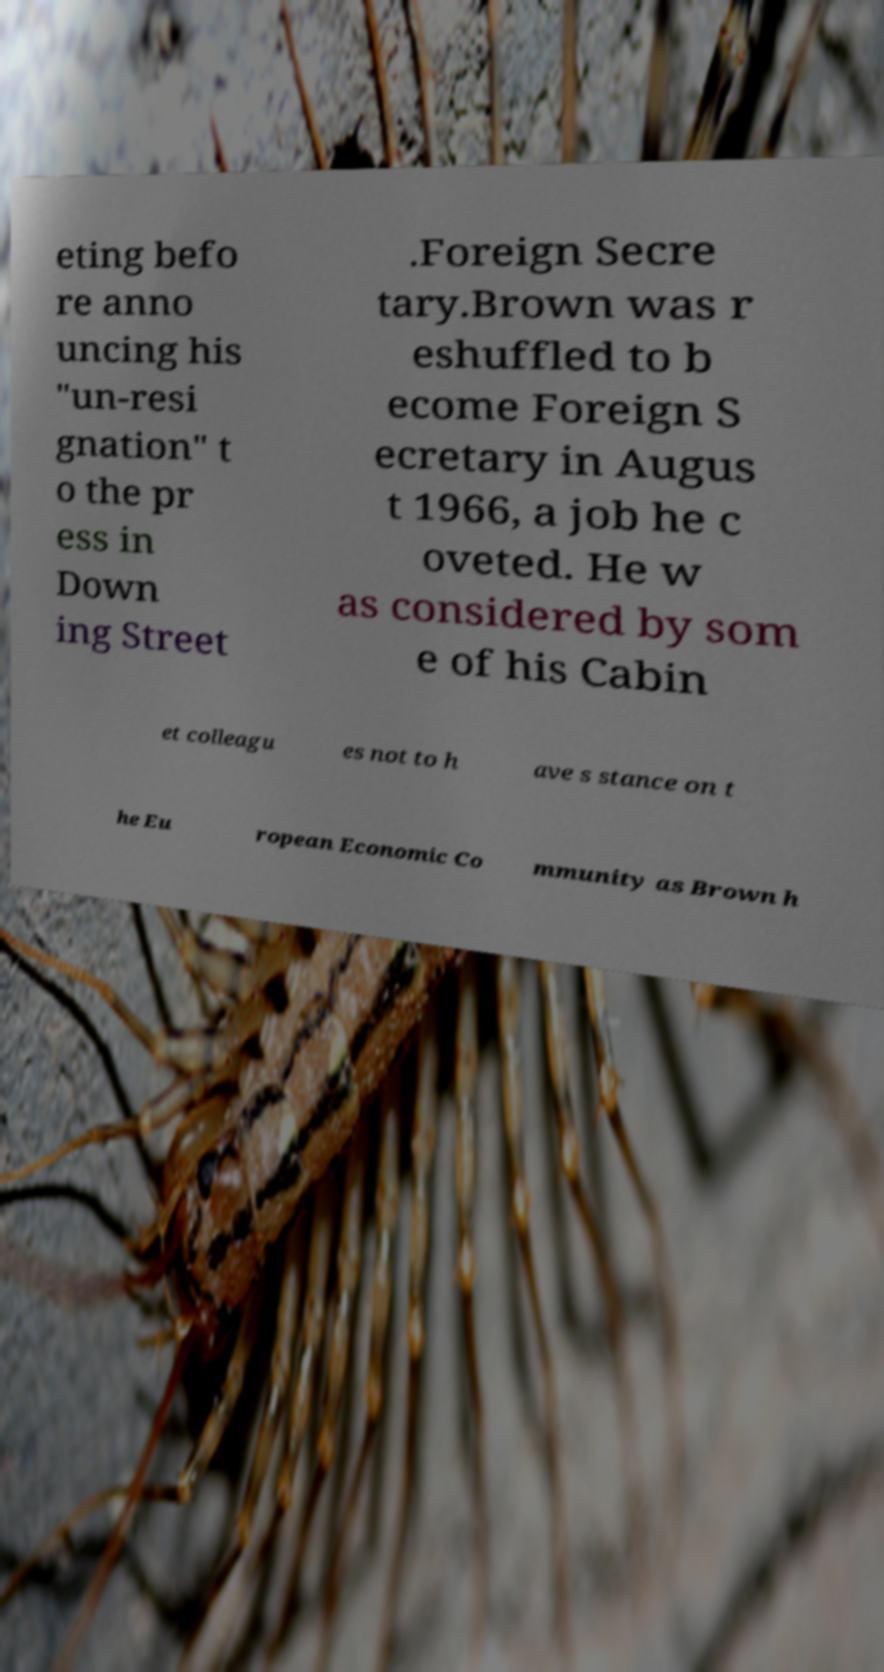For documentation purposes, I need the text within this image transcribed. Could you provide that? eting befo re anno uncing his "un-resi gnation" t o the pr ess in Down ing Street .Foreign Secre tary.Brown was r eshuffled to b ecome Foreign S ecretary in Augus t 1966, a job he c oveted. He w as considered by som e of his Cabin et colleagu es not to h ave s stance on t he Eu ropean Economic Co mmunity as Brown h 